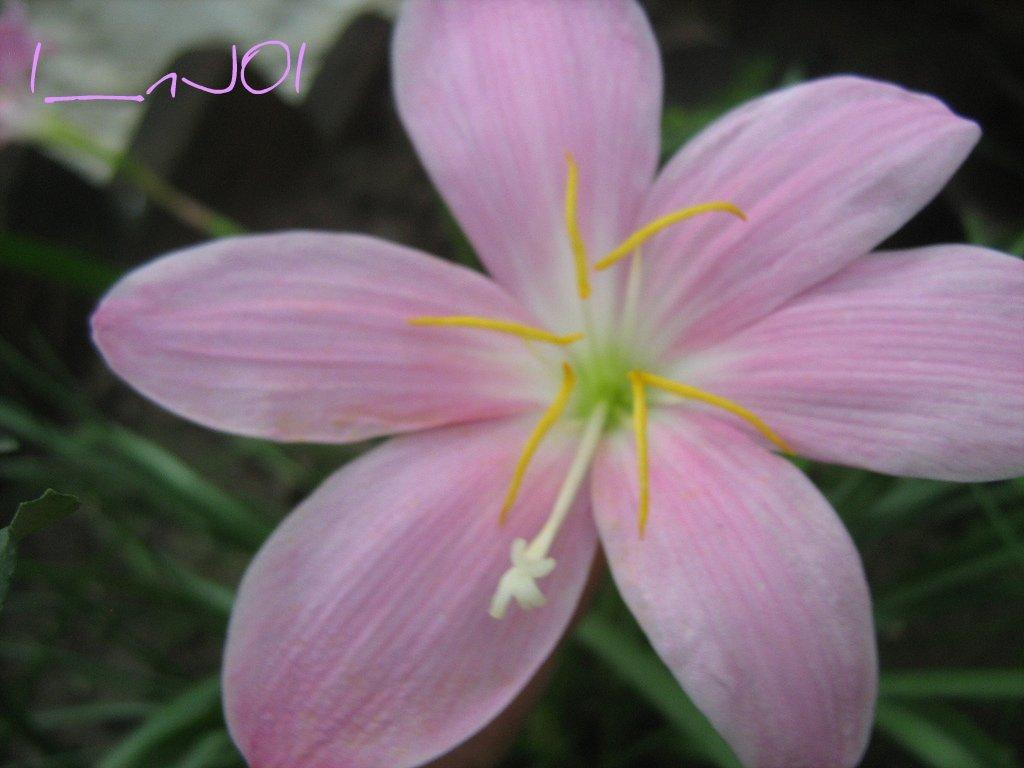What is the main subject of the picture? The main subject of the picture is a pink flower. Can you describe the background of the image? The background of the image is blurred. What type of car can be seen driving through the apple orchard in the image? There is no car or apple orchard present in the image; it features a pink flower with a blurred background. 